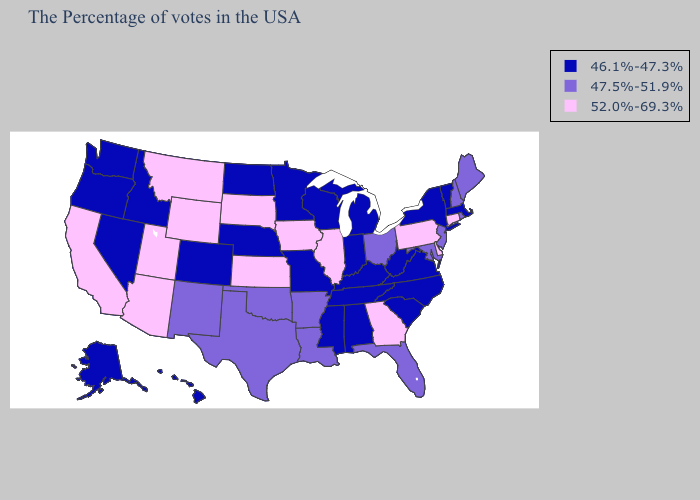Among the states that border Mississippi , which have the highest value?
Quick response, please. Louisiana, Arkansas. Does Massachusetts have the lowest value in the Northeast?
Quick response, please. Yes. What is the value of Iowa?
Give a very brief answer. 52.0%-69.3%. Which states have the lowest value in the MidWest?
Answer briefly. Michigan, Indiana, Wisconsin, Missouri, Minnesota, Nebraska, North Dakota. Among the states that border Massachusetts , does New Hampshire have the highest value?
Concise answer only. No. What is the value of Maryland?
Be succinct. 47.5%-51.9%. What is the value of Oregon?
Keep it brief. 46.1%-47.3%. Among the states that border Maryland , which have the highest value?
Quick response, please. Delaware, Pennsylvania. How many symbols are there in the legend?
Write a very short answer. 3. Does Iowa have the lowest value in the MidWest?
Short answer required. No. Among the states that border Indiana , does Michigan have the lowest value?
Give a very brief answer. Yes. Name the states that have a value in the range 46.1%-47.3%?
Short answer required. Massachusetts, Vermont, New York, Virginia, North Carolina, South Carolina, West Virginia, Michigan, Kentucky, Indiana, Alabama, Tennessee, Wisconsin, Mississippi, Missouri, Minnesota, Nebraska, North Dakota, Colorado, Idaho, Nevada, Washington, Oregon, Alaska, Hawaii. How many symbols are there in the legend?
Quick response, please. 3. Name the states that have a value in the range 46.1%-47.3%?
Write a very short answer. Massachusetts, Vermont, New York, Virginia, North Carolina, South Carolina, West Virginia, Michigan, Kentucky, Indiana, Alabama, Tennessee, Wisconsin, Mississippi, Missouri, Minnesota, Nebraska, North Dakota, Colorado, Idaho, Nevada, Washington, Oregon, Alaska, Hawaii. Name the states that have a value in the range 47.5%-51.9%?
Concise answer only. Maine, Rhode Island, New Hampshire, New Jersey, Maryland, Ohio, Florida, Louisiana, Arkansas, Oklahoma, Texas, New Mexico. 